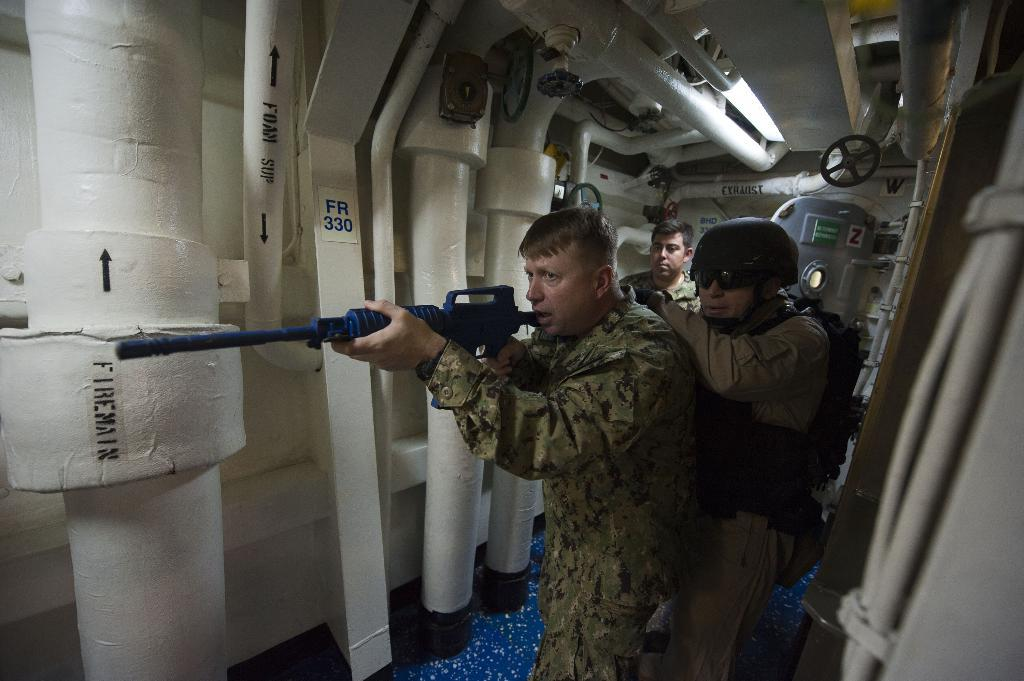What type of people can be seen in the image? There are military men in the image. What are the military men holding in the image? The military men are holding guns. Where are the military men located in the image? The military men are standing inside a ship tunnel. What can be seen in the background of the image? There is a ship door visible in the background. What is present on the top of the image? There are pipes on the top in the image. What type of advertisement can be seen on the ship door in the image? There is no advertisement present on the ship door in the image. How does the behavior of the military men change throughout the image? The image only shows a single moment in time, so it is not possible to determine any changes in the behavior of the military men. 